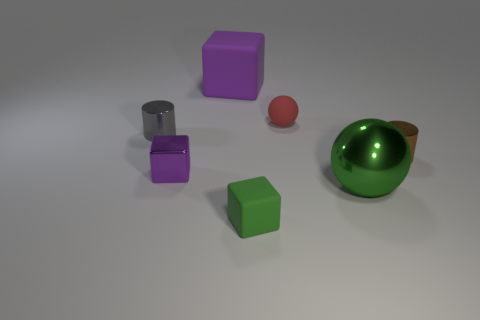The rubber sphere that is the same size as the brown thing is what color?
Provide a short and direct response. Red. Does the small red thing have the same shape as the green object to the left of the red ball?
Provide a short and direct response. No. The metal sphere that is the same color as the tiny rubber block is what size?
Ensure brevity in your answer.  Large. What number of things are either tiny gray cylinders or brown metallic cylinders?
Keep it short and to the point. 2. What shape is the big object that is on the left side of the sphere that is behind the small gray metal cylinder?
Your answer should be compact. Cube. Does the big thing that is in front of the small brown object have the same shape as the tiny red thing?
Keep it short and to the point. Yes. What is the size of the red object that is made of the same material as the tiny green thing?
Offer a very short reply. Small. How many things are either big objects that are right of the large purple matte thing or spheres in front of the small gray cylinder?
Make the answer very short. 1. Are there an equal number of gray metal cylinders that are behind the gray metal cylinder and metallic things right of the green matte thing?
Offer a terse response. No. What is the color of the thing that is behind the small red rubber thing?
Provide a short and direct response. Purple. 